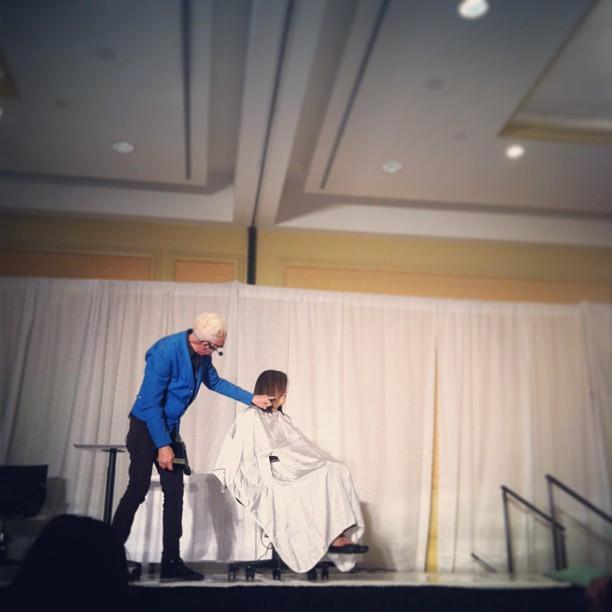What is the woman receiving on the stage?
From the following four choices, select the correct answer to address the question.
Options: Haircut, award, diploma, book. Haircut. 